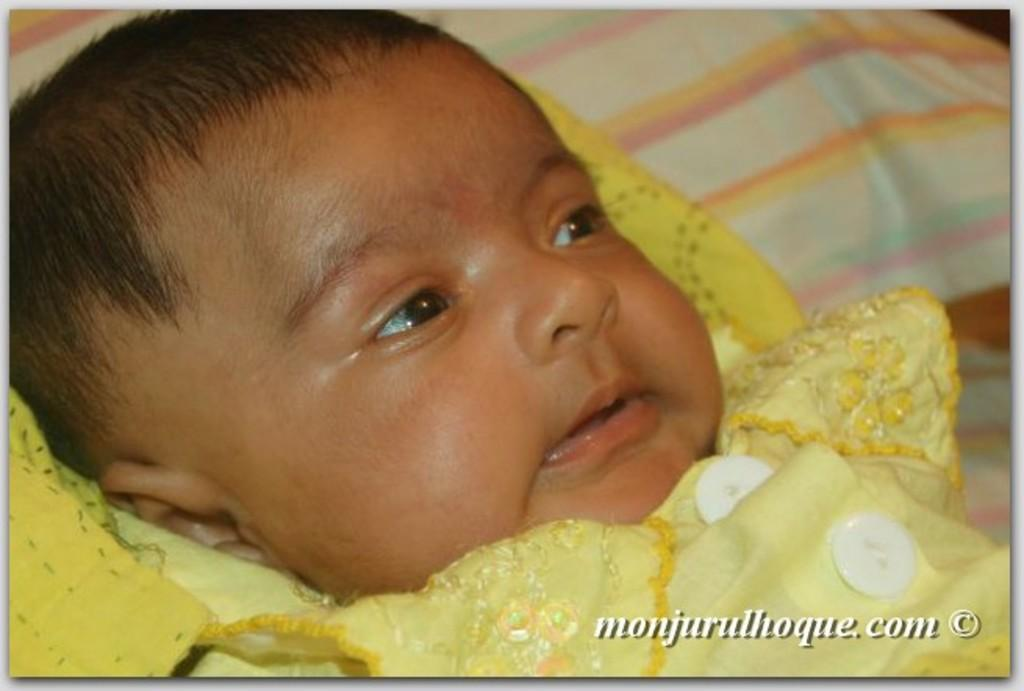What is the main subject of the image? There is a baby in the image. What is the baby wearing? The baby is wearing a yellow dress. What can be seen in the background of the image? There is a pillow in the background of the image. What is the baby's belief about the front of the man in the image? There is no man present in the image, so the baby's belief about the front of a man cannot be determined. 